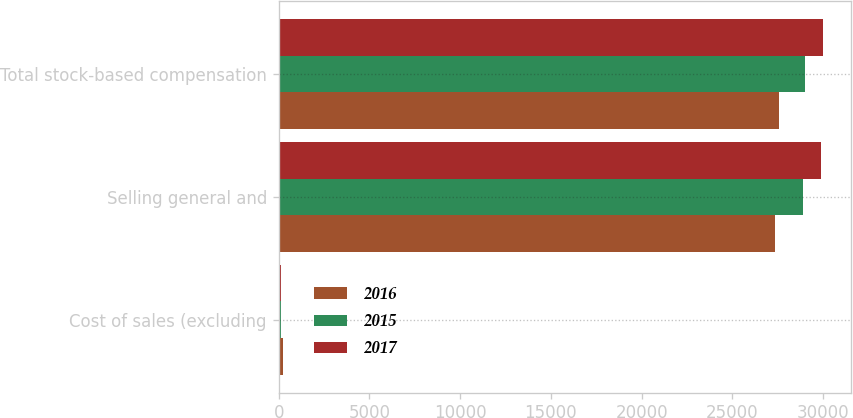Convert chart to OTSL. <chart><loc_0><loc_0><loc_500><loc_500><stacked_bar_chart><ecel><fcel>Cost of sales (excluding<fcel>Selling general and<fcel>Total stock-based compensation<nl><fcel>2016<fcel>220<fcel>27365<fcel>27585<nl><fcel>2015<fcel>110<fcel>28866<fcel>28976<nl><fcel>2017<fcel>108<fcel>29911<fcel>30019<nl></chart> 